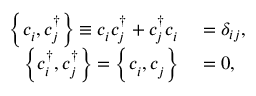Convert formula to latex. <formula><loc_0><loc_0><loc_500><loc_500>\begin{array} { r l } { \left \{ c _ { i } ^ { \, } , c _ { j } ^ { \dagger } \right \} \equiv c _ { i } ^ { \, } c _ { j } ^ { \dagger } + c _ { j } ^ { \dagger } c _ { i } ^ { \, } } & = \delta _ { i j } , } \\ { \left \{ c _ { i } ^ { \dagger } , c _ { j } ^ { \dagger } \right \} = \left \{ c _ { i } ^ { \, } , c _ { j } ^ { \, } \right \} } & = 0 , } \end{array}</formula> 